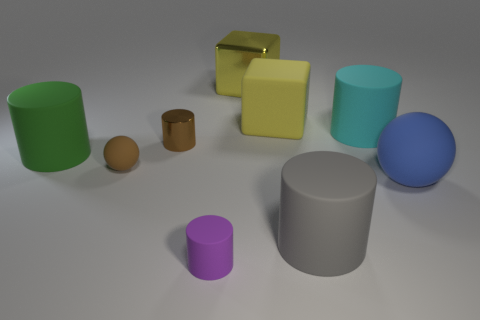What is the brown cylinder made of?
Your answer should be compact. Metal. Do the big green object and the small cylinder that is behind the blue object have the same material?
Offer a terse response. No. There is a shiny thing that is in front of the large matte object that is behind the cyan matte cylinder; what color is it?
Your answer should be very brief. Brown. There is a rubber cylinder that is behind the large blue sphere and to the left of the large yellow metallic cube; how big is it?
Your response must be concise. Large. What number of other things are the same shape as the gray matte object?
Offer a very short reply. 4. There is a yellow metallic object; does it have the same shape as the small metal thing behind the tiny rubber cylinder?
Offer a very short reply. No. There is a cyan thing; how many purple matte things are in front of it?
Keep it short and to the point. 1. Do the object in front of the gray rubber cylinder and the tiny shiny thing have the same shape?
Provide a short and direct response. Yes. What is the color of the small thing that is behind the big green matte cylinder?
Provide a short and direct response. Brown. There is a large cyan thing that is the same material as the big gray thing; what is its shape?
Your answer should be compact. Cylinder. 